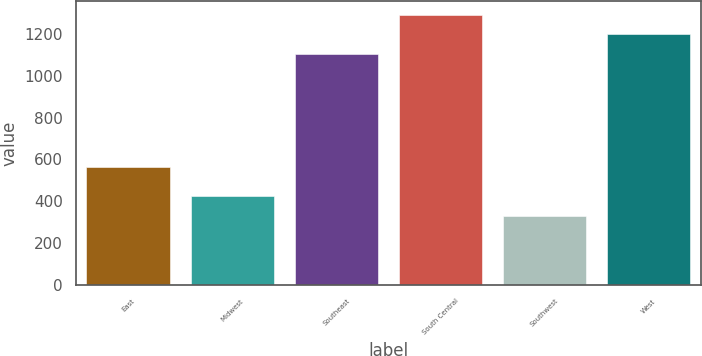<chart> <loc_0><loc_0><loc_500><loc_500><bar_chart><fcel>East<fcel>Midwest<fcel>Southeast<fcel>South Central<fcel>Southwest<fcel>West<nl><fcel>565.3<fcel>423.16<fcel>1101.9<fcel>1292.82<fcel>327.7<fcel>1197.36<nl></chart> 